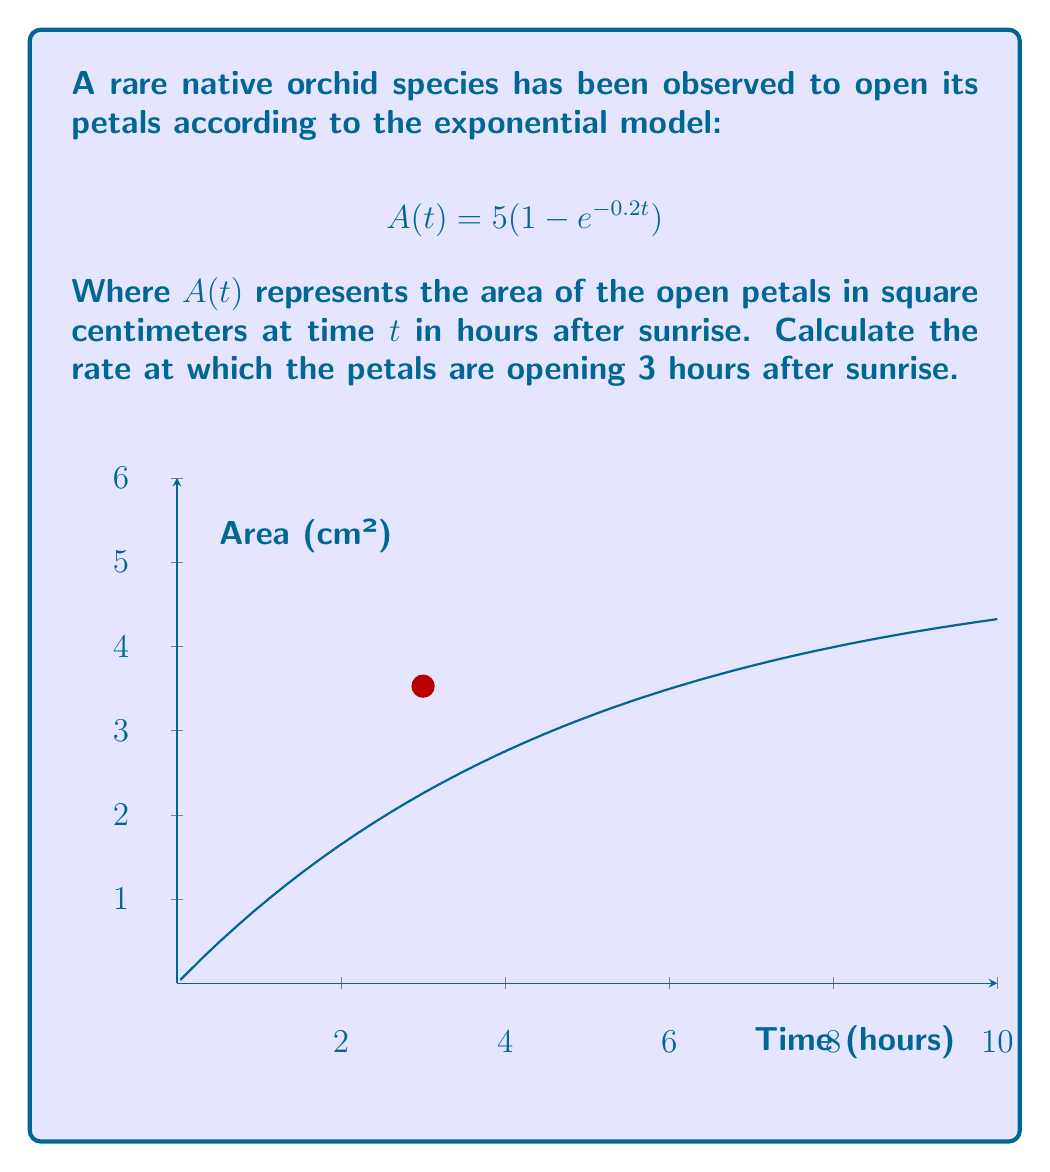Solve this math problem. To solve this problem, we need to find the derivative of $A(t)$ and then evaluate it at $t=3$. Here's the step-by-step process:

1) The given function is $A(t) = 5(1 - e^{-0.2t})$

2) To find the rate of change, we need to differentiate $A(t)$ with respect to $t$:

   $$\frac{dA}{dt} = 5 \cdot \frac{d}{dt}(1 - e^{-0.2t})$$

3) Using the chain rule:

   $$\frac{dA}{dt} = 5 \cdot (-1) \cdot (-0.2e^{-0.2t})$$

4) Simplifying:

   $$\frac{dA}{dt} = e^{-0.2t}$$

5) Now, we need to evaluate this at $t=3$:

   $$\left.\frac{dA}{dt}\right|_{t=3} = e^{-0.2(3)} = e^{-0.6}$$

6) Using a calculator or leaving it in exponential form:

   $$\left.\frac{dA}{dt}\right|_{t=3} \approx 0.5488 \text{ cm²/hour}$$

This rate represents how quickly the petals are opening 3 hours after sunrise.
Answer: $e^{-0.6}$ cm²/hour or approximately 0.5488 cm²/hour 